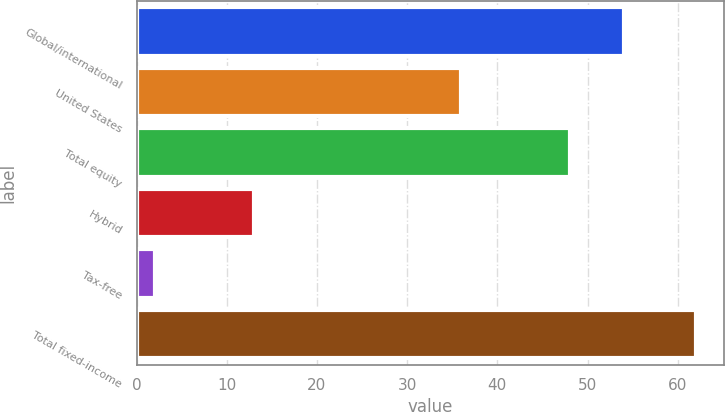Convert chart. <chart><loc_0><loc_0><loc_500><loc_500><bar_chart><fcel>Global/international<fcel>United States<fcel>Total equity<fcel>Hybrid<fcel>Tax-free<fcel>Total fixed-income<nl><fcel>54<fcel>36<fcel>48<fcel>13<fcel>2<fcel>62<nl></chart> 